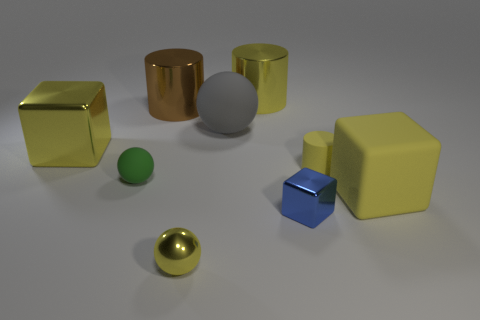Subtract all spheres. How many objects are left? 6 Add 9 green objects. How many green objects are left? 10 Add 7 large cylinders. How many large cylinders exist? 9 Subtract 0 brown balls. How many objects are left? 9 Subtract all large blue things. Subtract all blue metallic things. How many objects are left? 8 